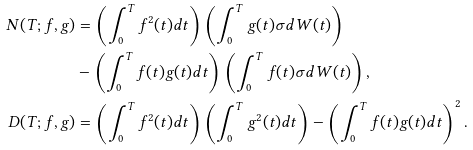Convert formula to latex. <formula><loc_0><loc_0><loc_500><loc_500>N ( T ; f , g ) & = \left ( \int _ { 0 } ^ { T } { f } ^ { 2 } ( t ) d t \right ) \left ( \int _ { 0 } ^ { T } g ( t ) \sigma d W ( t ) \right ) \\ & - \left ( \int _ { 0 } ^ { T } f ( t ) g ( t ) d t \right ) \left ( \int _ { 0 } ^ { T } f ( t ) \sigma d W ( t ) \right ) , \\ D ( T ; f , g ) & = \left ( \int _ { 0 } ^ { T } f ^ { 2 } ( t ) d t \right ) \left ( \int _ { 0 } ^ { T } g ^ { 2 } ( t ) d t \right ) - \left ( \int _ { 0 } ^ { T } f ( t ) g ( t ) d t \right ) ^ { 2 } .</formula> 